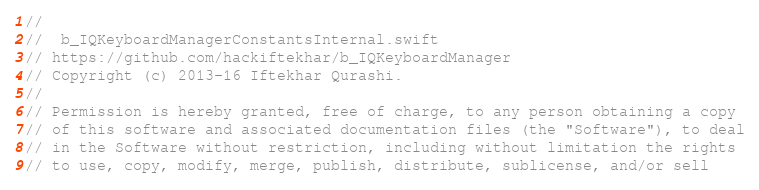<code> <loc_0><loc_0><loc_500><loc_500><_Swift_>//
//  b_IQKeyboardManagerConstantsInternal.swift
// https://github.com/hackiftekhar/b_IQKeyboardManager
// Copyright (c) 2013-16 Iftekhar Qurashi.
//
// Permission is hereby granted, free of charge, to any person obtaining a copy
// of this software and associated documentation files (the "Software"), to deal
// in the Software without restriction, including without limitation the rights
// to use, copy, modify, merge, publish, distribute, sublicense, and/or sell</code> 